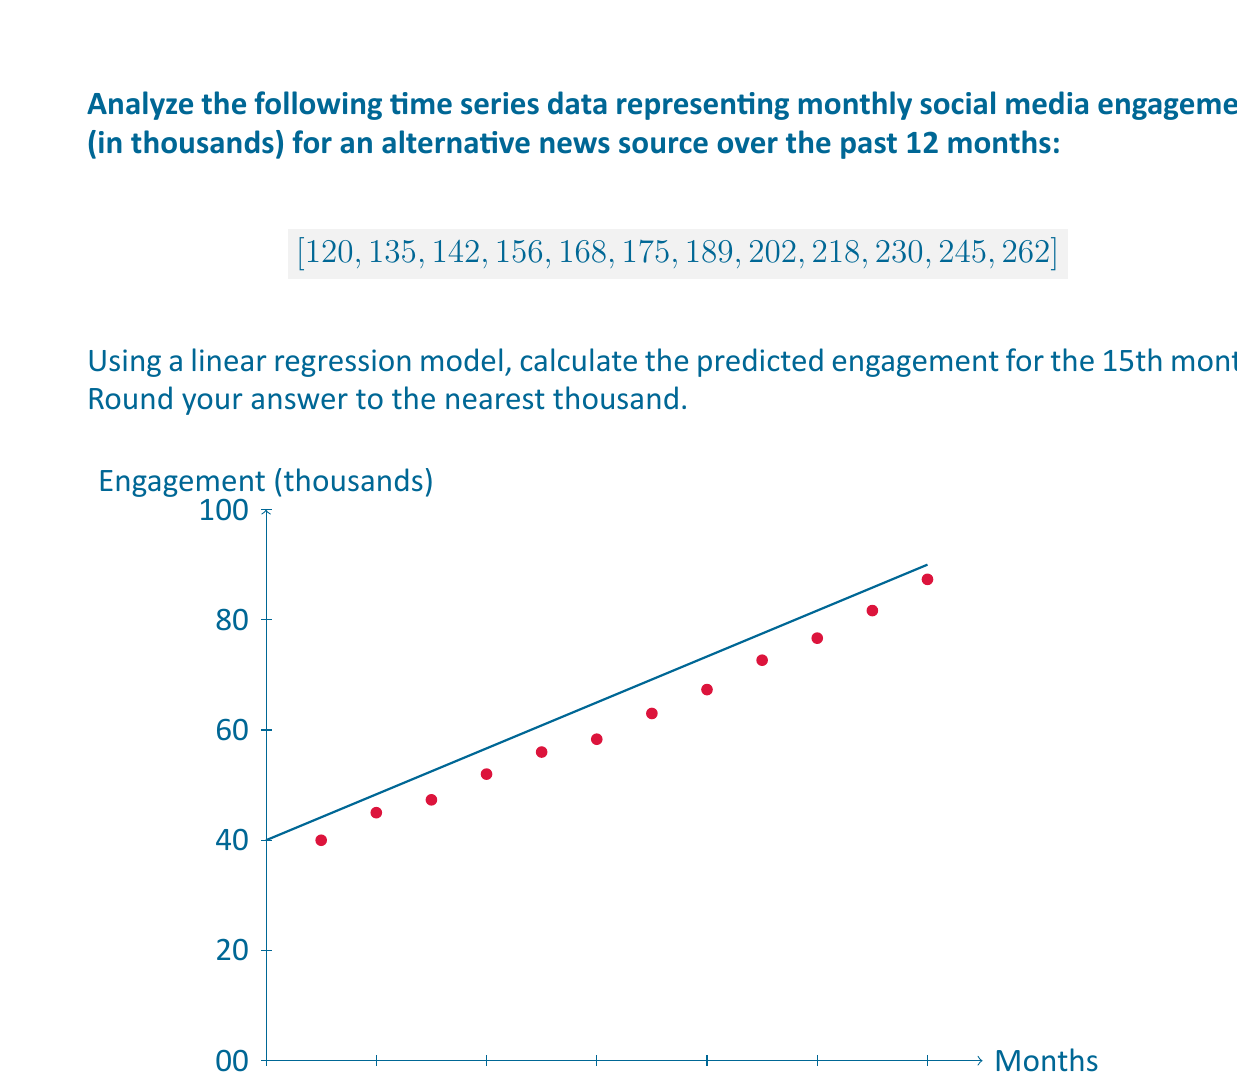Teach me how to tackle this problem. To solve this problem, we'll use a linear regression model:

1) First, calculate the slope (m) and y-intercept (b) of the line of best fit.

2) The formula for the slope is:
   $$m = \frac{n\sum xy - \sum x \sum y}{n\sum x^2 - (\sum x)^2}$$

3) Where n = 12 (number of months), x = month number, y = engagement

4) Calculate the necessary sums:
   $$\sum x = 78, \sum y = 2242, \sum xy = 16,718, \sum x^2 = 650$$

5) Plug into the slope formula:
   $$m = \frac{12(16,718) - 78(2242)}{12(650) - 78^2} = 12.93$$

6) Calculate the y-intercept using:
   $$b = \frac{\sum y - m\sum x}{n} = \frac{2242 - 12.93(78)}{12} = 111.24$$

7) The linear regression equation is:
   $$y = 12.93x + 111.24$$

8) To predict the 15th month, substitute x = 15:
   $$y = 12.93(15) + 111.24 = 305.19$$

9) Rounding to the nearest thousand: 305
Answer: 305,000 